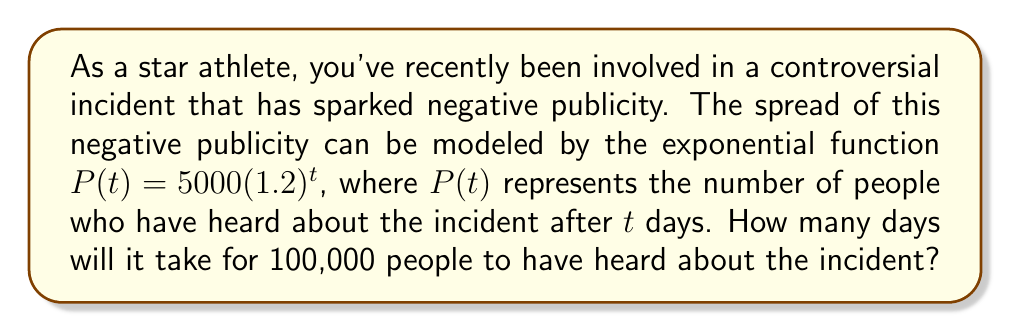Could you help me with this problem? To solve this problem, we need to use the given exponential function and determine when it reaches 100,000. Let's break it down step-by-step:

1) We start with the function: $P(t) = 5000(1.2)^t$

2) We want to find $t$ when $P(t) = 100,000$. So, we set up the equation:

   $100,000 = 5000(1.2)^t$

3) Divide both sides by 5000:

   $20 = (1.2)^t$

4) Now, we need to solve for $t$. We can do this by taking the logarithm of both sides. Let's use the natural logarithm (ln):

   $\ln(20) = \ln((1.2)^t)$

5) Using the logarithm property $\ln(a^b) = b\ln(a)$, we get:

   $\ln(20) = t\ln(1.2)$

6) Now we can solve for $t$:

   $t = \frac{\ln(20)}{\ln(1.2)}$

7) Using a calculator, we can compute this value:

   $t \approx 16.0357$

8) Since we're dealing with days, we need to round up to the next whole number, as it will take until the 17th day for the number to exceed 100,000.
Answer: It will take 17 days for 100,000 people to have heard about the incident. 